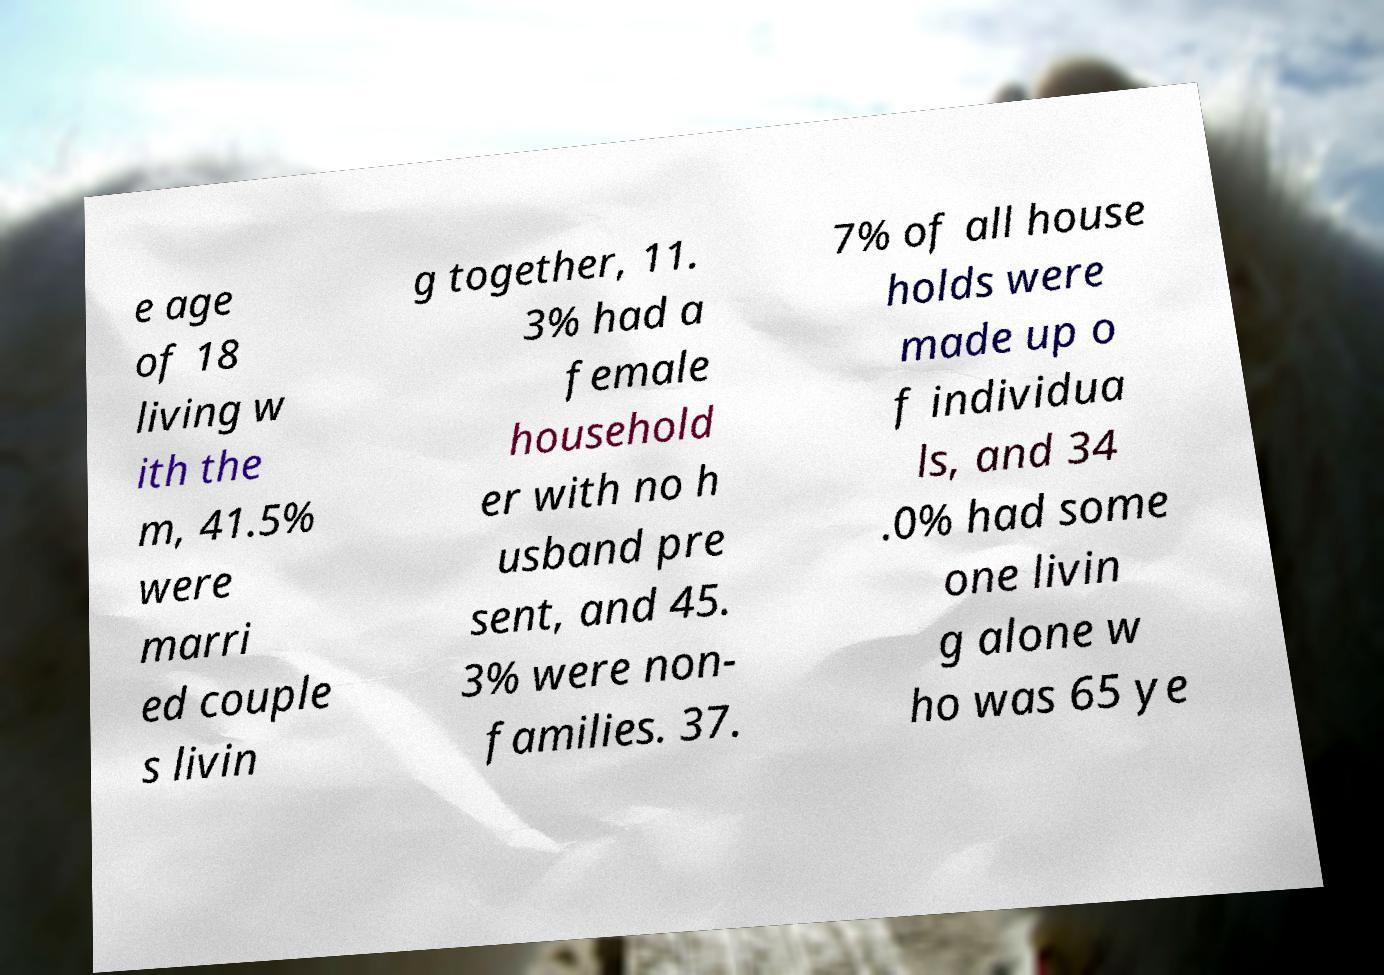There's text embedded in this image that I need extracted. Can you transcribe it verbatim? e age of 18 living w ith the m, 41.5% were marri ed couple s livin g together, 11. 3% had a female household er with no h usband pre sent, and 45. 3% were non- families. 37. 7% of all house holds were made up o f individua ls, and 34 .0% had some one livin g alone w ho was 65 ye 